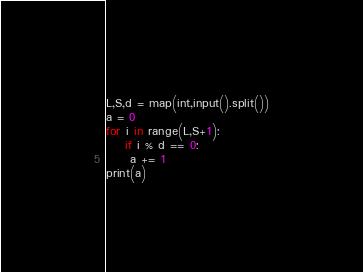Convert code to text. <code><loc_0><loc_0><loc_500><loc_500><_Python_>L,S,d = map(int,input().split())
a = 0
for i in range(L,S+1):
    if i % d == 0:
     a += 1
print(a)</code> 